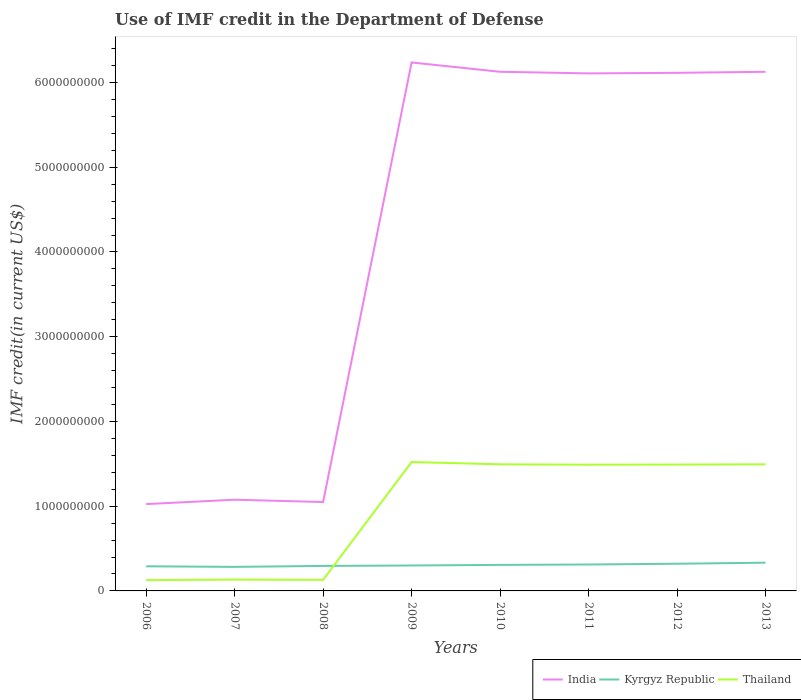Does the line corresponding to Thailand intersect with the line corresponding to Kyrgyz Republic?
Offer a very short reply. Yes. Across all years, what is the maximum IMF credit in the Department of Defense in Kyrgyz Republic?
Your response must be concise. 2.84e+08. What is the total IMF credit in the Department of Defense in Thailand in the graph?
Your response must be concise. -1.36e+09. What is the difference between the highest and the second highest IMF credit in the Department of Defense in India?
Your answer should be very brief. 5.21e+09. What is the difference between the highest and the lowest IMF credit in the Department of Defense in Thailand?
Offer a very short reply. 5. Is the IMF credit in the Department of Defense in Thailand strictly greater than the IMF credit in the Department of Defense in Kyrgyz Republic over the years?
Ensure brevity in your answer.  No. How many years are there in the graph?
Ensure brevity in your answer.  8. How many legend labels are there?
Offer a terse response. 3. How are the legend labels stacked?
Offer a very short reply. Horizontal. What is the title of the graph?
Give a very brief answer. Use of IMF credit in the Department of Defense. Does "Korea (Republic)" appear as one of the legend labels in the graph?
Offer a very short reply. No. What is the label or title of the X-axis?
Provide a succinct answer. Years. What is the label or title of the Y-axis?
Give a very brief answer. IMF credit(in current US$). What is the IMF credit(in current US$) of India in 2006?
Your answer should be compact. 1.02e+09. What is the IMF credit(in current US$) in Kyrgyz Republic in 2006?
Your answer should be very brief. 2.91e+08. What is the IMF credit(in current US$) of Thailand in 2006?
Offer a terse response. 1.27e+08. What is the IMF credit(in current US$) in India in 2007?
Provide a succinct answer. 1.08e+09. What is the IMF credit(in current US$) of Kyrgyz Republic in 2007?
Provide a succinct answer. 2.84e+08. What is the IMF credit(in current US$) of Thailand in 2007?
Make the answer very short. 1.34e+08. What is the IMF credit(in current US$) in India in 2008?
Ensure brevity in your answer.  1.05e+09. What is the IMF credit(in current US$) in Kyrgyz Republic in 2008?
Provide a succinct answer. 2.95e+08. What is the IMF credit(in current US$) of Thailand in 2008?
Offer a terse response. 1.30e+08. What is the IMF credit(in current US$) in India in 2009?
Ensure brevity in your answer.  6.24e+09. What is the IMF credit(in current US$) in Kyrgyz Republic in 2009?
Your answer should be very brief. 3.00e+08. What is the IMF credit(in current US$) of Thailand in 2009?
Keep it short and to the point. 1.52e+09. What is the IMF credit(in current US$) of India in 2010?
Your response must be concise. 6.13e+09. What is the IMF credit(in current US$) in Kyrgyz Republic in 2010?
Make the answer very short. 3.07e+08. What is the IMF credit(in current US$) in Thailand in 2010?
Your answer should be very brief. 1.49e+09. What is the IMF credit(in current US$) in India in 2011?
Your response must be concise. 6.11e+09. What is the IMF credit(in current US$) in Kyrgyz Republic in 2011?
Make the answer very short. 3.12e+08. What is the IMF credit(in current US$) in Thailand in 2011?
Provide a succinct answer. 1.49e+09. What is the IMF credit(in current US$) of India in 2012?
Offer a very short reply. 6.11e+09. What is the IMF credit(in current US$) in Kyrgyz Republic in 2012?
Your answer should be very brief. 3.21e+08. What is the IMF credit(in current US$) of Thailand in 2012?
Provide a succinct answer. 1.49e+09. What is the IMF credit(in current US$) in India in 2013?
Provide a short and direct response. 6.13e+09. What is the IMF credit(in current US$) in Kyrgyz Republic in 2013?
Your answer should be compact. 3.33e+08. What is the IMF credit(in current US$) of Thailand in 2013?
Provide a short and direct response. 1.49e+09. Across all years, what is the maximum IMF credit(in current US$) of India?
Provide a short and direct response. 6.24e+09. Across all years, what is the maximum IMF credit(in current US$) in Kyrgyz Republic?
Keep it short and to the point. 3.33e+08. Across all years, what is the maximum IMF credit(in current US$) of Thailand?
Your answer should be compact. 1.52e+09. Across all years, what is the minimum IMF credit(in current US$) in India?
Offer a very short reply. 1.02e+09. Across all years, what is the minimum IMF credit(in current US$) in Kyrgyz Republic?
Your answer should be very brief. 2.84e+08. Across all years, what is the minimum IMF credit(in current US$) of Thailand?
Your answer should be very brief. 1.27e+08. What is the total IMF credit(in current US$) in India in the graph?
Provide a succinct answer. 3.39e+1. What is the total IMF credit(in current US$) in Kyrgyz Republic in the graph?
Offer a very short reply. 2.44e+09. What is the total IMF credit(in current US$) of Thailand in the graph?
Provide a short and direct response. 7.88e+09. What is the difference between the IMF credit(in current US$) of India in 2006 and that in 2007?
Provide a succinct answer. -5.17e+07. What is the difference between the IMF credit(in current US$) of Kyrgyz Republic in 2006 and that in 2007?
Your answer should be compact. 6.81e+06. What is the difference between the IMF credit(in current US$) in Thailand in 2006 and that in 2007?
Provide a succinct answer. -6.42e+06. What is the difference between the IMF credit(in current US$) of India in 2006 and that in 2008?
Provide a short and direct response. -2.44e+07. What is the difference between the IMF credit(in current US$) of Kyrgyz Republic in 2006 and that in 2008?
Your response must be concise. -4.50e+06. What is the difference between the IMF credit(in current US$) in Thailand in 2006 and that in 2008?
Keep it short and to the point. -3.04e+06. What is the difference between the IMF credit(in current US$) of India in 2006 and that in 2009?
Your answer should be very brief. -5.21e+09. What is the difference between the IMF credit(in current US$) of Kyrgyz Republic in 2006 and that in 2009?
Ensure brevity in your answer.  -9.43e+06. What is the difference between the IMF credit(in current US$) in Thailand in 2006 and that in 2009?
Make the answer very short. -1.39e+09. What is the difference between the IMF credit(in current US$) of India in 2006 and that in 2010?
Your answer should be very brief. -5.10e+09. What is the difference between the IMF credit(in current US$) in Kyrgyz Republic in 2006 and that in 2010?
Your response must be concise. -1.66e+07. What is the difference between the IMF credit(in current US$) of Thailand in 2006 and that in 2010?
Your answer should be compact. -1.37e+09. What is the difference between the IMF credit(in current US$) in India in 2006 and that in 2011?
Keep it short and to the point. -5.08e+09. What is the difference between the IMF credit(in current US$) in Kyrgyz Republic in 2006 and that in 2011?
Give a very brief answer. -2.14e+07. What is the difference between the IMF credit(in current US$) of Thailand in 2006 and that in 2011?
Ensure brevity in your answer.  -1.36e+09. What is the difference between the IMF credit(in current US$) of India in 2006 and that in 2012?
Your answer should be compact. -5.09e+09. What is the difference between the IMF credit(in current US$) of Kyrgyz Republic in 2006 and that in 2012?
Offer a very short reply. -3.02e+07. What is the difference between the IMF credit(in current US$) of Thailand in 2006 and that in 2012?
Your answer should be very brief. -1.36e+09. What is the difference between the IMF credit(in current US$) of India in 2006 and that in 2013?
Your response must be concise. -5.10e+09. What is the difference between the IMF credit(in current US$) in Kyrgyz Republic in 2006 and that in 2013?
Provide a short and direct response. -4.27e+07. What is the difference between the IMF credit(in current US$) of Thailand in 2006 and that in 2013?
Make the answer very short. -1.37e+09. What is the difference between the IMF credit(in current US$) in India in 2007 and that in 2008?
Make the answer very short. 2.72e+07. What is the difference between the IMF credit(in current US$) in Kyrgyz Republic in 2007 and that in 2008?
Make the answer very short. -1.13e+07. What is the difference between the IMF credit(in current US$) in Thailand in 2007 and that in 2008?
Your answer should be very brief. 3.38e+06. What is the difference between the IMF credit(in current US$) in India in 2007 and that in 2009?
Ensure brevity in your answer.  -5.16e+09. What is the difference between the IMF credit(in current US$) of Kyrgyz Republic in 2007 and that in 2009?
Your response must be concise. -1.62e+07. What is the difference between the IMF credit(in current US$) in Thailand in 2007 and that in 2009?
Ensure brevity in your answer.  -1.39e+09. What is the difference between the IMF credit(in current US$) of India in 2007 and that in 2010?
Your response must be concise. -5.05e+09. What is the difference between the IMF credit(in current US$) of Kyrgyz Republic in 2007 and that in 2010?
Your answer should be very brief. -2.34e+07. What is the difference between the IMF credit(in current US$) of Thailand in 2007 and that in 2010?
Your answer should be very brief. -1.36e+09. What is the difference between the IMF credit(in current US$) of India in 2007 and that in 2011?
Give a very brief answer. -5.03e+09. What is the difference between the IMF credit(in current US$) in Kyrgyz Republic in 2007 and that in 2011?
Ensure brevity in your answer.  -2.82e+07. What is the difference between the IMF credit(in current US$) in Thailand in 2007 and that in 2011?
Keep it short and to the point. -1.36e+09. What is the difference between the IMF credit(in current US$) in India in 2007 and that in 2012?
Your answer should be compact. -5.04e+09. What is the difference between the IMF credit(in current US$) of Kyrgyz Republic in 2007 and that in 2012?
Your answer should be compact. -3.70e+07. What is the difference between the IMF credit(in current US$) in Thailand in 2007 and that in 2012?
Your answer should be very brief. -1.36e+09. What is the difference between the IMF credit(in current US$) of India in 2007 and that in 2013?
Offer a terse response. -5.05e+09. What is the difference between the IMF credit(in current US$) in Kyrgyz Republic in 2007 and that in 2013?
Your answer should be very brief. -4.95e+07. What is the difference between the IMF credit(in current US$) in Thailand in 2007 and that in 2013?
Make the answer very short. -1.36e+09. What is the difference between the IMF credit(in current US$) in India in 2008 and that in 2009?
Provide a short and direct response. -5.19e+09. What is the difference between the IMF credit(in current US$) in Kyrgyz Republic in 2008 and that in 2009?
Your answer should be very brief. -4.93e+06. What is the difference between the IMF credit(in current US$) in Thailand in 2008 and that in 2009?
Give a very brief answer. -1.39e+09. What is the difference between the IMF credit(in current US$) in India in 2008 and that in 2010?
Provide a short and direct response. -5.08e+09. What is the difference between the IMF credit(in current US$) of Kyrgyz Republic in 2008 and that in 2010?
Your answer should be very brief. -1.21e+07. What is the difference between the IMF credit(in current US$) in Thailand in 2008 and that in 2010?
Ensure brevity in your answer.  -1.36e+09. What is the difference between the IMF credit(in current US$) of India in 2008 and that in 2011?
Offer a terse response. -5.06e+09. What is the difference between the IMF credit(in current US$) of Kyrgyz Republic in 2008 and that in 2011?
Your response must be concise. -1.69e+07. What is the difference between the IMF credit(in current US$) in Thailand in 2008 and that in 2011?
Your response must be concise. -1.36e+09. What is the difference between the IMF credit(in current US$) in India in 2008 and that in 2012?
Ensure brevity in your answer.  -5.07e+09. What is the difference between the IMF credit(in current US$) of Kyrgyz Republic in 2008 and that in 2012?
Offer a terse response. -2.57e+07. What is the difference between the IMF credit(in current US$) in Thailand in 2008 and that in 2012?
Your response must be concise. -1.36e+09. What is the difference between the IMF credit(in current US$) of India in 2008 and that in 2013?
Offer a terse response. -5.08e+09. What is the difference between the IMF credit(in current US$) of Kyrgyz Republic in 2008 and that in 2013?
Your answer should be compact. -3.82e+07. What is the difference between the IMF credit(in current US$) in Thailand in 2008 and that in 2013?
Your response must be concise. -1.36e+09. What is the difference between the IMF credit(in current US$) of India in 2009 and that in 2010?
Your answer should be very brief. 1.10e+08. What is the difference between the IMF credit(in current US$) of Kyrgyz Republic in 2009 and that in 2010?
Offer a terse response. -7.17e+06. What is the difference between the IMF credit(in current US$) of Thailand in 2009 and that in 2010?
Ensure brevity in your answer.  2.68e+07. What is the difference between the IMF credit(in current US$) of India in 2009 and that in 2011?
Give a very brief answer. 1.29e+08. What is the difference between the IMF credit(in current US$) of Kyrgyz Republic in 2009 and that in 2011?
Your answer should be compact. -1.19e+07. What is the difference between the IMF credit(in current US$) of Thailand in 2009 and that in 2011?
Provide a short and direct response. 3.15e+07. What is the difference between the IMF credit(in current US$) in India in 2009 and that in 2012?
Your response must be concise. 1.22e+08. What is the difference between the IMF credit(in current US$) of Kyrgyz Republic in 2009 and that in 2012?
Your answer should be compact. -2.08e+07. What is the difference between the IMF credit(in current US$) of Thailand in 2009 and that in 2012?
Your answer should be compact. 2.99e+07. What is the difference between the IMF credit(in current US$) of India in 2009 and that in 2013?
Provide a succinct answer. 1.10e+08. What is the difference between the IMF credit(in current US$) of Kyrgyz Republic in 2009 and that in 2013?
Provide a short and direct response. -3.32e+07. What is the difference between the IMF credit(in current US$) in Thailand in 2009 and that in 2013?
Your answer should be very brief. 2.69e+07. What is the difference between the IMF credit(in current US$) of India in 2010 and that in 2011?
Provide a short and direct response. 1.89e+07. What is the difference between the IMF credit(in current US$) in Kyrgyz Republic in 2010 and that in 2011?
Your answer should be very brief. -4.75e+06. What is the difference between the IMF credit(in current US$) of Thailand in 2010 and that in 2011?
Ensure brevity in your answer.  4.62e+06. What is the difference between the IMF credit(in current US$) of India in 2010 and that in 2012?
Your answer should be very brief. 1.24e+07. What is the difference between the IMF credit(in current US$) in Kyrgyz Republic in 2010 and that in 2012?
Provide a short and direct response. -1.36e+07. What is the difference between the IMF credit(in current US$) of Thailand in 2010 and that in 2012?
Make the answer very short. 3.02e+06. What is the difference between the IMF credit(in current US$) of India in 2010 and that in 2013?
Provide a succinct answer. 1.19e+05. What is the difference between the IMF credit(in current US$) of Kyrgyz Republic in 2010 and that in 2013?
Ensure brevity in your answer.  -2.61e+07. What is the difference between the IMF credit(in current US$) of Thailand in 2010 and that in 2013?
Your answer should be very brief. 2.90e+04. What is the difference between the IMF credit(in current US$) of India in 2011 and that in 2012?
Ensure brevity in your answer.  -6.56e+06. What is the difference between the IMF credit(in current US$) in Kyrgyz Republic in 2011 and that in 2012?
Provide a short and direct response. -8.87e+06. What is the difference between the IMF credit(in current US$) of Thailand in 2011 and that in 2012?
Your answer should be compact. -1.60e+06. What is the difference between the IMF credit(in current US$) in India in 2011 and that in 2013?
Provide a succinct answer. -1.88e+07. What is the difference between the IMF credit(in current US$) in Kyrgyz Republic in 2011 and that in 2013?
Offer a very short reply. -2.13e+07. What is the difference between the IMF credit(in current US$) of Thailand in 2011 and that in 2013?
Keep it short and to the point. -4.59e+06. What is the difference between the IMF credit(in current US$) in India in 2012 and that in 2013?
Make the answer very short. -1.23e+07. What is the difference between the IMF credit(in current US$) of Kyrgyz Republic in 2012 and that in 2013?
Your answer should be compact. -1.25e+07. What is the difference between the IMF credit(in current US$) of Thailand in 2012 and that in 2013?
Your answer should be very brief. -2.99e+06. What is the difference between the IMF credit(in current US$) of India in 2006 and the IMF credit(in current US$) of Kyrgyz Republic in 2007?
Provide a short and direct response. 7.41e+08. What is the difference between the IMF credit(in current US$) of India in 2006 and the IMF credit(in current US$) of Thailand in 2007?
Keep it short and to the point. 8.91e+08. What is the difference between the IMF credit(in current US$) of Kyrgyz Republic in 2006 and the IMF credit(in current US$) of Thailand in 2007?
Make the answer very short. 1.57e+08. What is the difference between the IMF credit(in current US$) in India in 2006 and the IMF credit(in current US$) in Kyrgyz Republic in 2008?
Keep it short and to the point. 7.30e+08. What is the difference between the IMF credit(in current US$) of India in 2006 and the IMF credit(in current US$) of Thailand in 2008?
Offer a very short reply. 8.94e+08. What is the difference between the IMF credit(in current US$) in Kyrgyz Republic in 2006 and the IMF credit(in current US$) in Thailand in 2008?
Your answer should be very brief. 1.60e+08. What is the difference between the IMF credit(in current US$) in India in 2006 and the IMF credit(in current US$) in Kyrgyz Republic in 2009?
Your answer should be compact. 7.25e+08. What is the difference between the IMF credit(in current US$) of India in 2006 and the IMF credit(in current US$) of Thailand in 2009?
Offer a very short reply. -4.96e+08. What is the difference between the IMF credit(in current US$) of Kyrgyz Republic in 2006 and the IMF credit(in current US$) of Thailand in 2009?
Give a very brief answer. -1.23e+09. What is the difference between the IMF credit(in current US$) of India in 2006 and the IMF credit(in current US$) of Kyrgyz Republic in 2010?
Provide a succinct answer. 7.18e+08. What is the difference between the IMF credit(in current US$) of India in 2006 and the IMF credit(in current US$) of Thailand in 2010?
Keep it short and to the point. -4.69e+08. What is the difference between the IMF credit(in current US$) of Kyrgyz Republic in 2006 and the IMF credit(in current US$) of Thailand in 2010?
Ensure brevity in your answer.  -1.20e+09. What is the difference between the IMF credit(in current US$) of India in 2006 and the IMF credit(in current US$) of Kyrgyz Republic in 2011?
Provide a succinct answer. 7.13e+08. What is the difference between the IMF credit(in current US$) in India in 2006 and the IMF credit(in current US$) in Thailand in 2011?
Ensure brevity in your answer.  -4.65e+08. What is the difference between the IMF credit(in current US$) of Kyrgyz Republic in 2006 and the IMF credit(in current US$) of Thailand in 2011?
Your answer should be compact. -1.20e+09. What is the difference between the IMF credit(in current US$) in India in 2006 and the IMF credit(in current US$) in Kyrgyz Republic in 2012?
Offer a very short reply. 7.04e+08. What is the difference between the IMF credit(in current US$) in India in 2006 and the IMF credit(in current US$) in Thailand in 2012?
Your answer should be compact. -4.66e+08. What is the difference between the IMF credit(in current US$) in Kyrgyz Republic in 2006 and the IMF credit(in current US$) in Thailand in 2012?
Your answer should be compact. -1.20e+09. What is the difference between the IMF credit(in current US$) of India in 2006 and the IMF credit(in current US$) of Kyrgyz Republic in 2013?
Your answer should be very brief. 6.92e+08. What is the difference between the IMF credit(in current US$) of India in 2006 and the IMF credit(in current US$) of Thailand in 2013?
Give a very brief answer. -4.69e+08. What is the difference between the IMF credit(in current US$) in Kyrgyz Republic in 2006 and the IMF credit(in current US$) in Thailand in 2013?
Your answer should be very brief. -1.20e+09. What is the difference between the IMF credit(in current US$) of India in 2007 and the IMF credit(in current US$) of Kyrgyz Republic in 2008?
Your answer should be very brief. 7.81e+08. What is the difference between the IMF credit(in current US$) in India in 2007 and the IMF credit(in current US$) in Thailand in 2008?
Your answer should be compact. 9.46e+08. What is the difference between the IMF credit(in current US$) of Kyrgyz Republic in 2007 and the IMF credit(in current US$) of Thailand in 2008?
Your response must be concise. 1.53e+08. What is the difference between the IMF credit(in current US$) of India in 2007 and the IMF credit(in current US$) of Kyrgyz Republic in 2009?
Your answer should be very brief. 7.76e+08. What is the difference between the IMF credit(in current US$) in India in 2007 and the IMF credit(in current US$) in Thailand in 2009?
Make the answer very short. -4.45e+08. What is the difference between the IMF credit(in current US$) of Kyrgyz Republic in 2007 and the IMF credit(in current US$) of Thailand in 2009?
Provide a short and direct response. -1.24e+09. What is the difference between the IMF credit(in current US$) in India in 2007 and the IMF credit(in current US$) in Kyrgyz Republic in 2010?
Keep it short and to the point. 7.69e+08. What is the difference between the IMF credit(in current US$) of India in 2007 and the IMF credit(in current US$) of Thailand in 2010?
Make the answer very short. -4.18e+08. What is the difference between the IMF credit(in current US$) of Kyrgyz Republic in 2007 and the IMF credit(in current US$) of Thailand in 2010?
Offer a very short reply. -1.21e+09. What is the difference between the IMF credit(in current US$) of India in 2007 and the IMF credit(in current US$) of Kyrgyz Republic in 2011?
Your response must be concise. 7.65e+08. What is the difference between the IMF credit(in current US$) of India in 2007 and the IMF credit(in current US$) of Thailand in 2011?
Provide a succinct answer. -4.13e+08. What is the difference between the IMF credit(in current US$) in Kyrgyz Republic in 2007 and the IMF credit(in current US$) in Thailand in 2011?
Offer a terse response. -1.21e+09. What is the difference between the IMF credit(in current US$) in India in 2007 and the IMF credit(in current US$) in Kyrgyz Republic in 2012?
Make the answer very short. 7.56e+08. What is the difference between the IMF credit(in current US$) of India in 2007 and the IMF credit(in current US$) of Thailand in 2012?
Your answer should be compact. -4.15e+08. What is the difference between the IMF credit(in current US$) of Kyrgyz Republic in 2007 and the IMF credit(in current US$) of Thailand in 2012?
Keep it short and to the point. -1.21e+09. What is the difference between the IMF credit(in current US$) in India in 2007 and the IMF credit(in current US$) in Kyrgyz Republic in 2013?
Keep it short and to the point. 7.43e+08. What is the difference between the IMF credit(in current US$) of India in 2007 and the IMF credit(in current US$) of Thailand in 2013?
Give a very brief answer. -4.18e+08. What is the difference between the IMF credit(in current US$) of Kyrgyz Republic in 2007 and the IMF credit(in current US$) of Thailand in 2013?
Ensure brevity in your answer.  -1.21e+09. What is the difference between the IMF credit(in current US$) of India in 2008 and the IMF credit(in current US$) of Kyrgyz Republic in 2009?
Your answer should be very brief. 7.49e+08. What is the difference between the IMF credit(in current US$) of India in 2008 and the IMF credit(in current US$) of Thailand in 2009?
Keep it short and to the point. -4.72e+08. What is the difference between the IMF credit(in current US$) of Kyrgyz Republic in 2008 and the IMF credit(in current US$) of Thailand in 2009?
Make the answer very short. -1.23e+09. What is the difference between the IMF credit(in current US$) in India in 2008 and the IMF credit(in current US$) in Kyrgyz Republic in 2010?
Your answer should be very brief. 7.42e+08. What is the difference between the IMF credit(in current US$) of India in 2008 and the IMF credit(in current US$) of Thailand in 2010?
Your answer should be very brief. -4.45e+08. What is the difference between the IMF credit(in current US$) of Kyrgyz Republic in 2008 and the IMF credit(in current US$) of Thailand in 2010?
Offer a very short reply. -1.20e+09. What is the difference between the IMF credit(in current US$) of India in 2008 and the IMF credit(in current US$) of Kyrgyz Republic in 2011?
Offer a very short reply. 7.37e+08. What is the difference between the IMF credit(in current US$) of India in 2008 and the IMF credit(in current US$) of Thailand in 2011?
Keep it short and to the point. -4.40e+08. What is the difference between the IMF credit(in current US$) in Kyrgyz Republic in 2008 and the IMF credit(in current US$) in Thailand in 2011?
Keep it short and to the point. -1.19e+09. What is the difference between the IMF credit(in current US$) in India in 2008 and the IMF credit(in current US$) in Kyrgyz Republic in 2012?
Offer a very short reply. 7.28e+08. What is the difference between the IMF credit(in current US$) of India in 2008 and the IMF credit(in current US$) of Thailand in 2012?
Your response must be concise. -4.42e+08. What is the difference between the IMF credit(in current US$) in Kyrgyz Republic in 2008 and the IMF credit(in current US$) in Thailand in 2012?
Give a very brief answer. -1.20e+09. What is the difference between the IMF credit(in current US$) in India in 2008 and the IMF credit(in current US$) in Kyrgyz Republic in 2013?
Make the answer very short. 7.16e+08. What is the difference between the IMF credit(in current US$) of India in 2008 and the IMF credit(in current US$) of Thailand in 2013?
Your response must be concise. -4.45e+08. What is the difference between the IMF credit(in current US$) of Kyrgyz Republic in 2008 and the IMF credit(in current US$) of Thailand in 2013?
Ensure brevity in your answer.  -1.20e+09. What is the difference between the IMF credit(in current US$) of India in 2009 and the IMF credit(in current US$) of Kyrgyz Republic in 2010?
Keep it short and to the point. 5.93e+09. What is the difference between the IMF credit(in current US$) of India in 2009 and the IMF credit(in current US$) of Thailand in 2010?
Provide a short and direct response. 4.74e+09. What is the difference between the IMF credit(in current US$) of Kyrgyz Republic in 2009 and the IMF credit(in current US$) of Thailand in 2010?
Your response must be concise. -1.19e+09. What is the difference between the IMF credit(in current US$) of India in 2009 and the IMF credit(in current US$) of Kyrgyz Republic in 2011?
Give a very brief answer. 5.92e+09. What is the difference between the IMF credit(in current US$) of India in 2009 and the IMF credit(in current US$) of Thailand in 2011?
Your answer should be compact. 4.75e+09. What is the difference between the IMF credit(in current US$) of Kyrgyz Republic in 2009 and the IMF credit(in current US$) of Thailand in 2011?
Your answer should be compact. -1.19e+09. What is the difference between the IMF credit(in current US$) in India in 2009 and the IMF credit(in current US$) in Kyrgyz Republic in 2012?
Provide a short and direct response. 5.92e+09. What is the difference between the IMF credit(in current US$) of India in 2009 and the IMF credit(in current US$) of Thailand in 2012?
Ensure brevity in your answer.  4.75e+09. What is the difference between the IMF credit(in current US$) in Kyrgyz Republic in 2009 and the IMF credit(in current US$) in Thailand in 2012?
Offer a very short reply. -1.19e+09. What is the difference between the IMF credit(in current US$) of India in 2009 and the IMF credit(in current US$) of Kyrgyz Republic in 2013?
Your answer should be compact. 5.90e+09. What is the difference between the IMF credit(in current US$) of India in 2009 and the IMF credit(in current US$) of Thailand in 2013?
Offer a very short reply. 4.74e+09. What is the difference between the IMF credit(in current US$) of Kyrgyz Republic in 2009 and the IMF credit(in current US$) of Thailand in 2013?
Make the answer very short. -1.19e+09. What is the difference between the IMF credit(in current US$) of India in 2010 and the IMF credit(in current US$) of Kyrgyz Republic in 2011?
Provide a short and direct response. 5.81e+09. What is the difference between the IMF credit(in current US$) in India in 2010 and the IMF credit(in current US$) in Thailand in 2011?
Offer a very short reply. 4.64e+09. What is the difference between the IMF credit(in current US$) of Kyrgyz Republic in 2010 and the IMF credit(in current US$) of Thailand in 2011?
Provide a short and direct response. -1.18e+09. What is the difference between the IMF credit(in current US$) of India in 2010 and the IMF credit(in current US$) of Kyrgyz Republic in 2012?
Keep it short and to the point. 5.81e+09. What is the difference between the IMF credit(in current US$) of India in 2010 and the IMF credit(in current US$) of Thailand in 2012?
Make the answer very short. 4.64e+09. What is the difference between the IMF credit(in current US$) of Kyrgyz Republic in 2010 and the IMF credit(in current US$) of Thailand in 2012?
Your answer should be compact. -1.18e+09. What is the difference between the IMF credit(in current US$) in India in 2010 and the IMF credit(in current US$) in Kyrgyz Republic in 2013?
Ensure brevity in your answer.  5.79e+09. What is the difference between the IMF credit(in current US$) of India in 2010 and the IMF credit(in current US$) of Thailand in 2013?
Your answer should be compact. 4.63e+09. What is the difference between the IMF credit(in current US$) of Kyrgyz Republic in 2010 and the IMF credit(in current US$) of Thailand in 2013?
Provide a succinct answer. -1.19e+09. What is the difference between the IMF credit(in current US$) of India in 2011 and the IMF credit(in current US$) of Kyrgyz Republic in 2012?
Make the answer very short. 5.79e+09. What is the difference between the IMF credit(in current US$) of India in 2011 and the IMF credit(in current US$) of Thailand in 2012?
Your answer should be very brief. 4.62e+09. What is the difference between the IMF credit(in current US$) in Kyrgyz Republic in 2011 and the IMF credit(in current US$) in Thailand in 2012?
Offer a terse response. -1.18e+09. What is the difference between the IMF credit(in current US$) in India in 2011 and the IMF credit(in current US$) in Kyrgyz Republic in 2013?
Give a very brief answer. 5.77e+09. What is the difference between the IMF credit(in current US$) of India in 2011 and the IMF credit(in current US$) of Thailand in 2013?
Offer a terse response. 4.61e+09. What is the difference between the IMF credit(in current US$) in Kyrgyz Republic in 2011 and the IMF credit(in current US$) in Thailand in 2013?
Keep it short and to the point. -1.18e+09. What is the difference between the IMF credit(in current US$) in India in 2012 and the IMF credit(in current US$) in Kyrgyz Republic in 2013?
Your answer should be very brief. 5.78e+09. What is the difference between the IMF credit(in current US$) of India in 2012 and the IMF credit(in current US$) of Thailand in 2013?
Your answer should be compact. 4.62e+09. What is the difference between the IMF credit(in current US$) of Kyrgyz Republic in 2012 and the IMF credit(in current US$) of Thailand in 2013?
Offer a very short reply. -1.17e+09. What is the average IMF credit(in current US$) in India per year?
Provide a short and direct response. 4.23e+09. What is the average IMF credit(in current US$) of Kyrgyz Republic per year?
Offer a very short reply. 3.05e+08. What is the average IMF credit(in current US$) of Thailand per year?
Offer a very short reply. 9.85e+08. In the year 2006, what is the difference between the IMF credit(in current US$) of India and IMF credit(in current US$) of Kyrgyz Republic?
Offer a very short reply. 7.34e+08. In the year 2006, what is the difference between the IMF credit(in current US$) of India and IMF credit(in current US$) of Thailand?
Keep it short and to the point. 8.97e+08. In the year 2006, what is the difference between the IMF credit(in current US$) of Kyrgyz Republic and IMF credit(in current US$) of Thailand?
Give a very brief answer. 1.63e+08. In the year 2007, what is the difference between the IMF credit(in current US$) of India and IMF credit(in current US$) of Kyrgyz Republic?
Ensure brevity in your answer.  7.93e+08. In the year 2007, what is the difference between the IMF credit(in current US$) of India and IMF credit(in current US$) of Thailand?
Keep it short and to the point. 9.43e+08. In the year 2007, what is the difference between the IMF credit(in current US$) in Kyrgyz Republic and IMF credit(in current US$) in Thailand?
Give a very brief answer. 1.50e+08. In the year 2008, what is the difference between the IMF credit(in current US$) of India and IMF credit(in current US$) of Kyrgyz Republic?
Provide a short and direct response. 7.54e+08. In the year 2008, what is the difference between the IMF credit(in current US$) in India and IMF credit(in current US$) in Thailand?
Ensure brevity in your answer.  9.19e+08. In the year 2008, what is the difference between the IMF credit(in current US$) of Kyrgyz Republic and IMF credit(in current US$) of Thailand?
Offer a terse response. 1.65e+08. In the year 2009, what is the difference between the IMF credit(in current US$) in India and IMF credit(in current US$) in Kyrgyz Republic?
Your answer should be compact. 5.94e+09. In the year 2009, what is the difference between the IMF credit(in current US$) of India and IMF credit(in current US$) of Thailand?
Ensure brevity in your answer.  4.72e+09. In the year 2009, what is the difference between the IMF credit(in current US$) of Kyrgyz Republic and IMF credit(in current US$) of Thailand?
Your answer should be compact. -1.22e+09. In the year 2010, what is the difference between the IMF credit(in current US$) of India and IMF credit(in current US$) of Kyrgyz Republic?
Keep it short and to the point. 5.82e+09. In the year 2010, what is the difference between the IMF credit(in current US$) in India and IMF credit(in current US$) in Thailand?
Give a very brief answer. 4.63e+09. In the year 2010, what is the difference between the IMF credit(in current US$) of Kyrgyz Republic and IMF credit(in current US$) of Thailand?
Give a very brief answer. -1.19e+09. In the year 2011, what is the difference between the IMF credit(in current US$) of India and IMF credit(in current US$) of Kyrgyz Republic?
Ensure brevity in your answer.  5.80e+09. In the year 2011, what is the difference between the IMF credit(in current US$) of India and IMF credit(in current US$) of Thailand?
Make the answer very short. 4.62e+09. In the year 2011, what is the difference between the IMF credit(in current US$) in Kyrgyz Republic and IMF credit(in current US$) in Thailand?
Your answer should be very brief. -1.18e+09. In the year 2012, what is the difference between the IMF credit(in current US$) in India and IMF credit(in current US$) in Kyrgyz Republic?
Ensure brevity in your answer.  5.79e+09. In the year 2012, what is the difference between the IMF credit(in current US$) in India and IMF credit(in current US$) in Thailand?
Offer a terse response. 4.62e+09. In the year 2012, what is the difference between the IMF credit(in current US$) in Kyrgyz Republic and IMF credit(in current US$) in Thailand?
Offer a terse response. -1.17e+09. In the year 2013, what is the difference between the IMF credit(in current US$) of India and IMF credit(in current US$) of Kyrgyz Republic?
Your response must be concise. 5.79e+09. In the year 2013, what is the difference between the IMF credit(in current US$) of India and IMF credit(in current US$) of Thailand?
Ensure brevity in your answer.  4.63e+09. In the year 2013, what is the difference between the IMF credit(in current US$) in Kyrgyz Republic and IMF credit(in current US$) in Thailand?
Provide a succinct answer. -1.16e+09. What is the ratio of the IMF credit(in current US$) of Thailand in 2006 to that in 2007?
Make the answer very short. 0.95. What is the ratio of the IMF credit(in current US$) of India in 2006 to that in 2008?
Keep it short and to the point. 0.98. What is the ratio of the IMF credit(in current US$) in Kyrgyz Republic in 2006 to that in 2008?
Make the answer very short. 0.98. What is the ratio of the IMF credit(in current US$) in Thailand in 2006 to that in 2008?
Ensure brevity in your answer.  0.98. What is the ratio of the IMF credit(in current US$) of India in 2006 to that in 2009?
Ensure brevity in your answer.  0.16. What is the ratio of the IMF credit(in current US$) in Kyrgyz Republic in 2006 to that in 2009?
Your answer should be very brief. 0.97. What is the ratio of the IMF credit(in current US$) in Thailand in 2006 to that in 2009?
Give a very brief answer. 0.08. What is the ratio of the IMF credit(in current US$) of India in 2006 to that in 2010?
Give a very brief answer. 0.17. What is the ratio of the IMF credit(in current US$) of Kyrgyz Republic in 2006 to that in 2010?
Offer a terse response. 0.95. What is the ratio of the IMF credit(in current US$) in Thailand in 2006 to that in 2010?
Give a very brief answer. 0.09. What is the ratio of the IMF credit(in current US$) in India in 2006 to that in 2011?
Your answer should be compact. 0.17. What is the ratio of the IMF credit(in current US$) of Kyrgyz Republic in 2006 to that in 2011?
Your response must be concise. 0.93. What is the ratio of the IMF credit(in current US$) of Thailand in 2006 to that in 2011?
Provide a succinct answer. 0.09. What is the ratio of the IMF credit(in current US$) of India in 2006 to that in 2012?
Your answer should be compact. 0.17. What is the ratio of the IMF credit(in current US$) in Kyrgyz Republic in 2006 to that in 2012?
Keep it short and to the point. 0.91. What is the ratio of the IMF credit(in current US$) of Thailand in 2006 to that in 2012?
Keep it short and to the point. 0.09. What is the ratio of the IMF credit(in current US$) of India in 2006 to that in 2013?
Offer a terse response. 0.17. What is the ratio of the IMF credit(in current US$) in Kyrgyz Republic in 2006 to that in 2013?
Your answer should be compact. 0.87. What is the ratio of the IMF credit(in current US$) of Thailand in 2006 to that in 2013?
Provide a succinct answer. 0.09. What is the ratio of the IMF credit(in current US$) in India in 2007 to that in 2008?
Your answer should be compact. 1.03. What is the ratio of the IMF credit(in current US$) of Kyrgyz Republic in 2007 to that in 2008?
Keep it short and to the point. 0.96. What is the ratio of the IMF credit(in current US$) of India in 2007 to that in 2009?
Give a very brief answer. 0.17. What is the ratio of the IMF credit(in current US$) of Kyrgyz Republic in 2007 to that in 2009?
Make the answer very short. 0.95. What is the ratio of the IMF credit(in current US$) in Thailand in 2007 to that in 2009?
Keep it short and to the point. 0.09. What is the ratio of the IMF credit(in current US$) in India in 2007 to that in 2010?
Provide a succinct answer. 0.18. What is the ratio of the IMF credit(in current US$) in Kyrgyz Republic in 2007 to that in 2010?
Offer a terse response. 0.92. What is the ratio of the IMF credit(in current US$) in Thailand in 2007 to that in 2010?
Your response must be concise. 0.09. What is the ratio of the IMF credit(in current US$) in India in 2007 to that in 2011?
Give a very brief answer. 0.18. What is the ratio of the IMF credit(in current US$) in Kyrgyz Republic in 2007 to that in 2011?
Your answer should be very brief. 0.91. What is the ratio of the IMF credit(in current US$) in Thailand in 2007 to that in 2011?
Make the answer very short. 0.09. What is the ratio of the IMF credit(in current US$) in India in 2007 to that in 2012?
Ensure brevity in your answer.  0.18. What is the ratio of the IMF credit(in current US$) of Kyrgyz Republic in 2007 to that in 2012?
Give a very brief answer. 0.88. What is the ratio of the IMF credit(in current US$) of Thailand in 2007 to that in 2012?
Provide a short and direct response. 0.09. What is the ratio of the IMF credit(in current US$) of India in 2007 to that in 2013?
Offer a terse response. 0.18. What is the ratio of the IMF credit(in current US$) of Kyrgyz Republic in 2007 to that in 2013?
Your answer should be compact. 0.85. What is the ratio of the IMF credit(in current US$) of Thailand in 2007 to that in 2013?
Keep it short and to the point. 0.09. What is the ratio of the IMF credit(in current US$) of India in 2008 to that in 2009?
Provide a succinct answer. 0.17. What is the ratio of the IMF credit(in current US$) of Kyrgyz Republic in 2008 to that in 2009?
Ensure brevity in your answer.  0.98. What is the ratio of the IMF credit(in current US$) of Thailand in 2008 to that in 2009?
Keep it short and to the point. 0.09. What is the ratio of the IMF credit(in current US$) of India in 2008 to that in 2010?
Keep it short and to the point. 0.17. What is the ratio of the IMF credit(in current US$) of Kyrgyz Republic in 2008 to that in 2010?
Keep it short and to the point. 0.96. What is the ratio of the IMF credit(in current US$) in Thailand in 2008 to that in 2010?
Your response must be concise. 0.09. What is the ratio of the IMF credit(in current US$) in India in 2008 to that in 2011?
Provide a succinct answer. 0.17. What is the ratio of the IMF credit(in current US$) in Kyrgyz Republic in 2008 to that in 2011?
Keep it short and to the point. 0.95. What is the ratio of the IMF credit(in current US$) of Thailand in 2008 to that in 2011?
Provide a succinct answer. 0.09. What is the ratio of the IMF credit(in current US$) in India in 2008 to that in 2012?
Your answer should be very brief. 0.17. What is the ratio of the IMF credit(in current US$) of Kyrgyz Republic in 2008 to that in 2012?
Keep it short and to the point. 0.92. What is the ratio of the IMF credit(in current US$) in Thailand in 2008 to that in 2012?
Offer a terse response. 0.09. What is the ratio of the IMF credit(in current US$) of India in 2008 to that in 2013?
Ensure brevity in your answer.  0.17. What is the ratio of the IMF credit(in current US$) in Kyrgyz Republic in 2008 to that in 2013?
Make the answer very short. 0.89. What is the ratio of the IMF credit(in current US$) of Thailand in 2008 to that in 2013?
Make the answer very short. 0.09. What is the ratio of the IMF credit(in current US$) of India in 2009 to that in 2010?
Make the answer very short. 1.02. What is the ratio of the IMF credit(in current US$) of Kyrgyz Republic in 2009 to that in 2010?
Provide a short and direct response. 0.98. What is the ratio of the IMF credit(in current US$) in India in 2009 to that in 2011?
Your response must be concise. 1.02. What is the ratio of the IMF credit(in current US$) in Kyrgyz Republic in 2009 to that in 2011?
Your response must be concise. 0.96. What is the ratio of the IMF credit(in current US$) of Thailand in 2009 to that in 2011?
Make the answer very short. 1.02. What is the ratio of the IMF credit(in current US$) of India in 2009 to that in 2012?
Make the answer very short. 1.02. What is the ratio of the IMF credit(in current US$) in Kyrgyz Republic in 2009 to that in 2012?
Keep it short and to the point. 0.94. What is the ratio of the IMF credit(in current US$) of Thailand in 2009 to that in 2012?
Provide a short and direct response. 1.02. What is the ratio of the IMF credit(in current US$) of Kyrgyz Republic in 2009 to that in 2013?
Make the answer very short. 0.9. What is the ratio of the IMF credit(in current US$) of Thailand in 2009 to that in 2013?
Provide a short and direct response. 1.02. What is the ratio of the IMF credit(in current US$) of Kyrgyz Republic in 2010 to that in 2011?
Your response must be concise. 0.98. What is the ratio of the IMF credit(in current US$) in Thailand in 2010 to that in 2011?
Make the answer very short. 1. What is the ratio of the IMF credit(in current US$) of Kyrgyz Republic in 2010 to that in 2012?
Keep it short and to the point. 0.96. What is the ratio of the IMF credit(in current US$) of Kyrgyz Republic in 2010 to that in 2013?
Your answer should be very brief. 0.92. What is the ratio of the IMF credit(in current US$) in India in 2011 to that in 2012?
Offer a very short reply. 1. What is the ratio of the IMF credit(in current US$) in Kyrgyz Republic in 2011 to that in 2012?
Keep it short and to the point. 0.97. What is the ratio of the IMF credit(in current US$) of Kyrgyz Republic in 2011 to that in 2013?
Make the answer very short. 0.94. What is the ratio of the IMF credit(in current US$) in Thailand in 2011 to that in 2013?
Give a very brief answer. 1. What is the ratio of the IMF credit(in current US$) of Kyrgyz Republic in 2012 to that in 2013?
Provide a short and direct response. 0.96. What is the ratio of the IMF credit(in current US$) in Thailand in 2012 to that in 2013?
Provide a succinct answer. 1. What is the difference between the highest and the second highest IMF credit(in current US$) of India?
Make the answer very short. 1.10e+08. What is the difference between the highest and the second highest IMF credit(in current US$) of Kyrgyz Republic?
Give a very brief answer. 1.25e+07. What is the difference between the highest and the second highest IMF credit(in current US$) of Thailand?
Make the answer very short. 2.68e+07. What is the difference between the highest and the lowest IMF credit(in current US$) of India?
Keep it short and to the point. 5.21e+09. What is the difference between the highest and the lowest IMF credit(in current US$) of Kyrgyz Republic?
Provide a short and direct response. 4.95e+07. What is the difference between the highest and the lowest IMF credit(in current US$) of Thailand?
Offer a very short reply. 1.39e+09. 